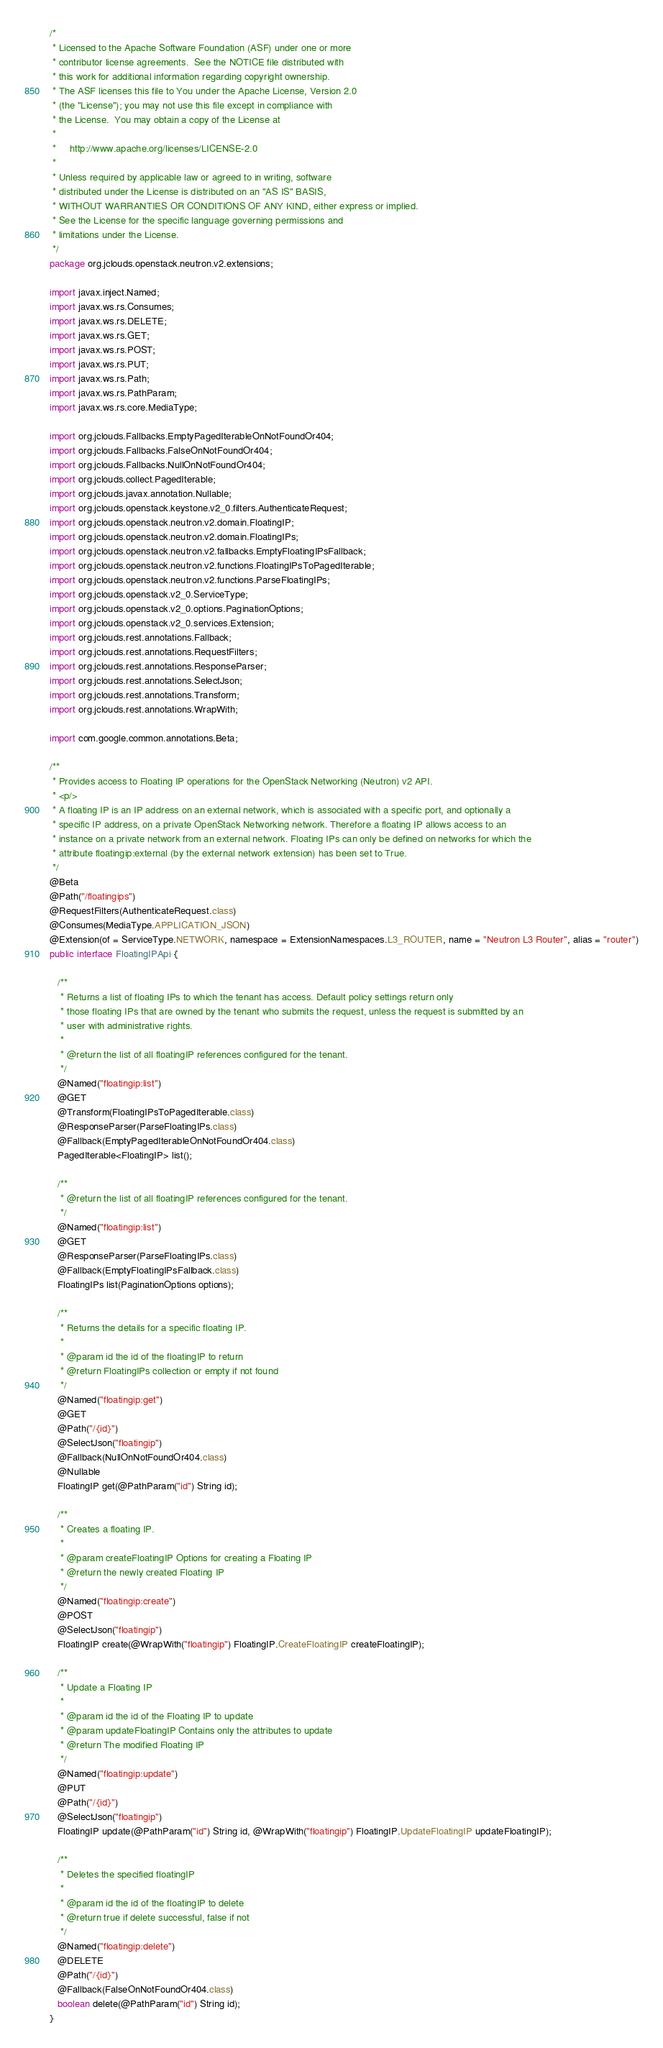Convert code to text. <code><loc_0><loc_0><loc_500><loc_500><_Java_>/*
 * Licensed to the Apache Software Foundation (ASF) under one or more
 * contributor license agreements.  See the NOTICE file distributed with
 * this work for additional information regarding copyright ownership.
 * The ASF licenses this file to You under the Apache License, Version 2.0
 * (the "License"); you may not use this file except in compliance with
 * the License.  You may obtain a copy of the License at
 *
 *     http://www.apache.org/licenses/LICENSE-2.0
 *
 * Unless required by applicable law or agreed to in writing, software
 * distributed under the License is distributed on an "AS IS" BASIS,
 * WITHOUT WARRANTIES OR CONDITIONS OF ANY KIND, either express or implied.
 * See the License for the specific language governing permissions and
 * limitations under the License.
 */
package org.jclouds.openstack.neutron.v2.extensions;

import javax.inject.Named;
import javax.ws.rs.Consumes;
import javax.ws.rs.DELETE;
import javax.ws.rs.GET;
import javax.ws.rs.POST;
import javax.ws.rs.PUT;
import javax.ws.rs.Path;
import javax.ws.rs.PathParam;
import javax.ws.rs.core.MediaType;

import org.jclouds.Fallbacks.EmptyPagedIterableOnNotFoundOr404;
import org.jclouds.Fallbacks.FalseOnNotFoundOr404;
import org.jclouds.Fallbacks.NullOnNotFoundOr404;
import org.jclouds.collect.PagedIterable;
import org.jclouds.javax.annotation.Nullable;
import org.jclouds.openstack.keystone.v2_0.filters.AuthenticateRequest;
import org.jclouds.openstack.neutron.v2.domain.FloatingIP;
import org.jclouds.openstack.neutron.v2.domain.FloatingIPs;
import org.jclouds.openstack.neutron.v2.fallbacks.EmptyFloatingIPsFallback;
import org.jclouds.openstack.neutron.v2.functions.FloatingIPsToPagedIterable;
import org.jclouds.openstack.neutron.v2.functions.ParseFloatingIPs;
import org.jclouds.openstack.v2_0.ServiceType;
import org.jclouds.openstack.v2_0.options.PaginationOptions;
import org.jclouds.openstack.v2_0.services.Extension;
import org.jclouds.rest.annotations.Fallback;
import org.jclouds.rest.annotations.RequestFilters;
import org.jclouds.rest.annotations.ResponseParser;
import org.jclouds.rest.annotations.SelectJson;
import org.jclouds.rest.annotations.Transform;
import org.jclouds.rest.annotations.WrapWith;

import com.google.common.annotations.Beta;

/**
 * Provides access to Floating IP operations for the OpenStack Networking (Neutron) v2 API.
 * <p/>
 * A floating IP is an IP address on an external network, which is associated with a specific port, and optionally a
 * specific IP address, on a private OpenStack Networking network. Therefore a floating IP allows access to an
 * instance on a private network from an external network. Floating IPs can only be defined on networks for which the
 * attribute floatingip:external (by the external network extension) has been set to True.
 */
@Beta
@Path("/floatingips")
@RequestFilters(AuthenticateRequest.class)
@Consumes(MediaType.APPLICATION_JSON)
@Extension(of = ServiceType.NETWORK, namespace = ExtensionNamespaces.L3_ROUTER, name = "Neutron L3 Router", alias = "router")
public interface FloatingIPApi {

   /**
    * Returns a list of floating IPs to which the tenant has access. Default policy settings return only
    * those floating IPs that are owned by the tenant who submits the request, unless the request is submitted by an
    * user with administrative rights.
    *
    * @return the list of all floatingIP references configured for the tenant.
    */
   @Named("floatingip:list")
   @GET
   @Transform(FloatingIPsToPagedIterable.class)
   @ResponseParser(ParseFloatingIPs.class)
   @Fallback(EmptyPagedIterableOnNotFoundOr404.class)
   PagedIterable<FloatingIP> list();

   /**
    * @return the list of all floatingIP references configured for the tenant.
    */
   @Named("floatingip:list")
   @GET
   @ResponseParser(ParseFloatingIPs.class)
   @Fallback(EmptyFloatingIPsFallback.class)
   FloatingIPs list(PaginationOptions options);

   /**
    * Returns the details for a specific floating IP.
    *
    * @param id the id of the floatingIP to return
    * @return FloatingIPs collection or empty if not found
    */
   @Named("floatingip:get")
   @GET
   @Path("/{id}")
   @SelectJson("floatingip")
   @Fallback(NullOnNotFoundOr404.class)
   @Nullable
   FloatingIP get(@PathParam("id") String id);

   /**
    * Creates a floating IP.
    *
    * @param createFloatingIP Options for creating a Floating IP
    * @return the newly created Floating IP
    */
   @Named("floatingip:create")
   @POST
   @SelectJson("floatingip")
   FloatingIP create(@WrapWith("floatingip") FloatingIP.CreateFloatingIP createFloatingIP);

   /**
    * Update a Floating IP
    *
    * @param id the id of the Floating IP to update
    * @param updateFloatingIP Contains only the attributes to update
    * @return The modified Floating IP
    */
   @Named("floatingip:update")
   @PUT
   @Path("/{id}")
   @SelectJson("floatingip")
   FloatingIP update(@PathParam("id") String id, @WrapWith("floatingip") FloatingIP.UpdateFloatingIP updateFloatingIP);

   /**
    * Deletes the specified floatingIP
    *
    * @param id the id of the floatingIP to delete
    * @return true if delete successful, false if not
    */
   @Named("floatingip:delete")
   @DELETE
   @Path("/{id}")
   @Fallback(FalseOnNotFoundOr404.class)
   boolean delete(@PathParam("id") String id);
}
</code> 